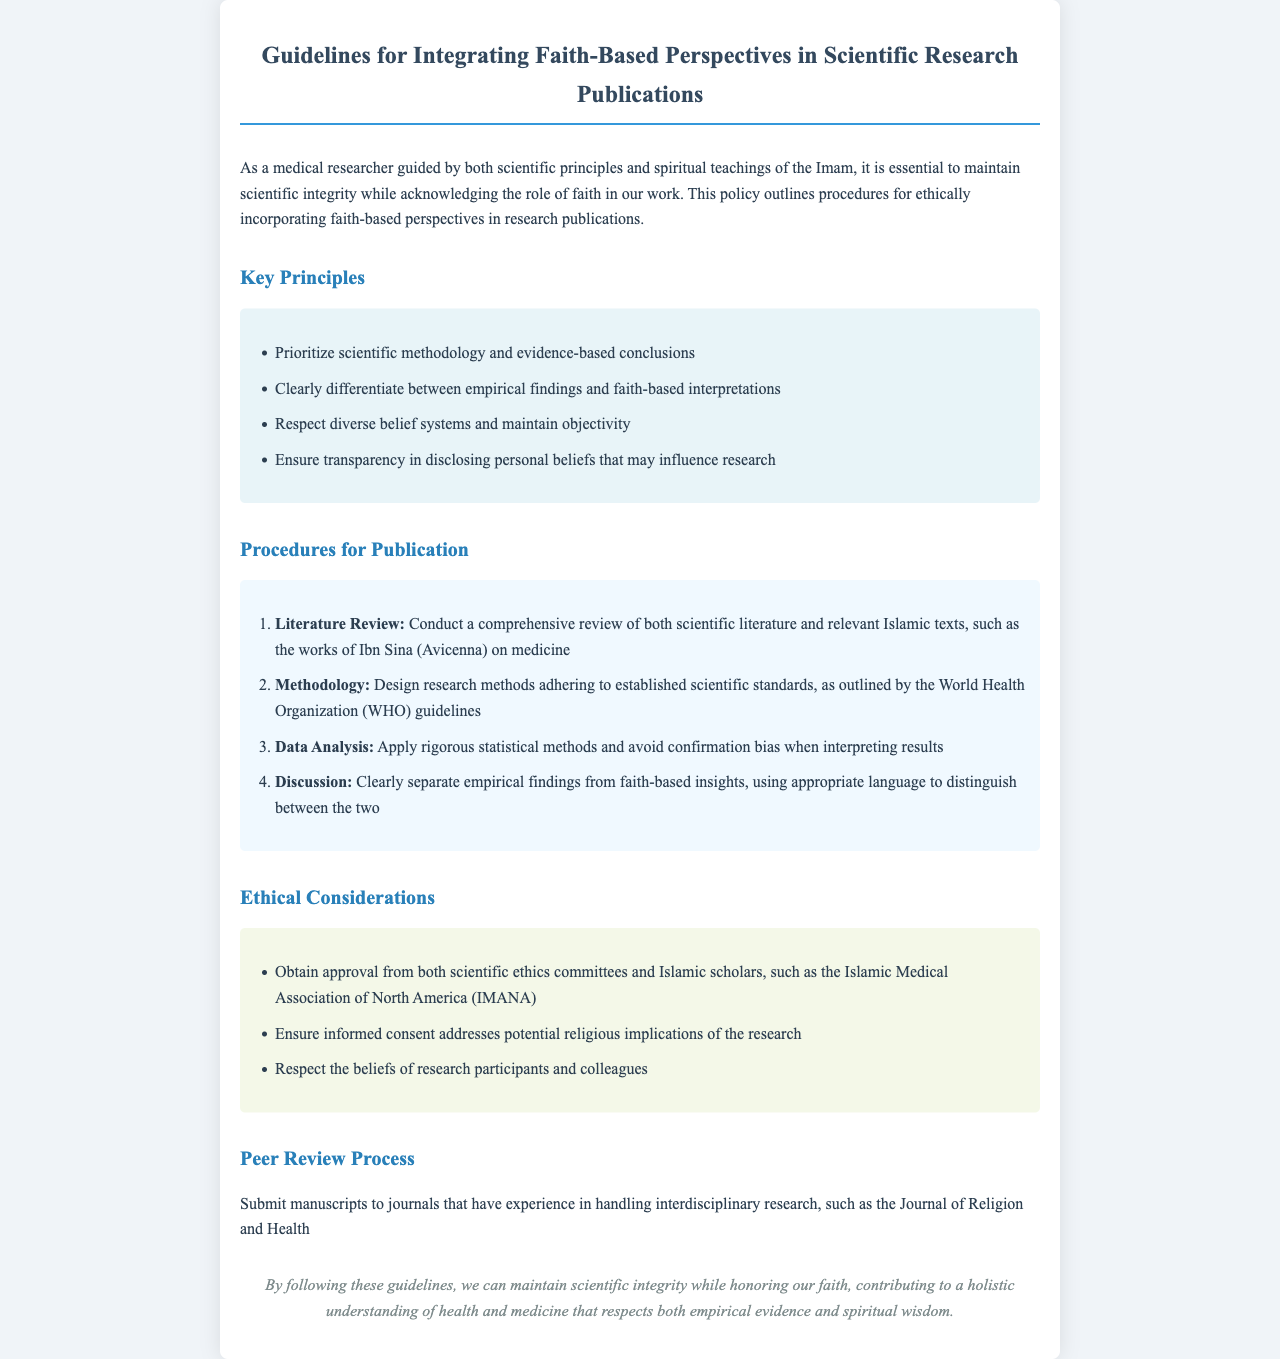what is the title of the document? The title is stated at the top and indicates the content and purpose of the document.
Answer: Guidelines for Integrating Faith-Based Perspectives in Scientific Research Publications how many key principles are listed in the document? The number of key principles is mentioned in the section titled "Key Principles."
Answer: Four what is the first procedure for publication? The first procedure is detailed in the "Procedures for Publication" section, describing the initial step researchers should take.
Answer: Literature Review which organization’s guidelines should the methodology adhere to? The document specifies a recognized authority in health and medicine to ensure methodological standards.
Answer: World Health Organization what is emphasized in the ethical considerations regarding participant beliefs? This aspect highlights the respect required for the diverse beliefs involved in the research.
Answer: Respect the beliefs of research participants and colleagues in which journal should researchers submit their manuscripts? The document suggests a journal that specializes in the intersection of health and spirituality for publication.
Answer: Journal of Religion and Health what should researchers obtain approval from in ethical considerations? The document outlines the necessary approvals needed from both scientific and religious domains.
Answer: Scientific ethics committees and Islamic scholars 